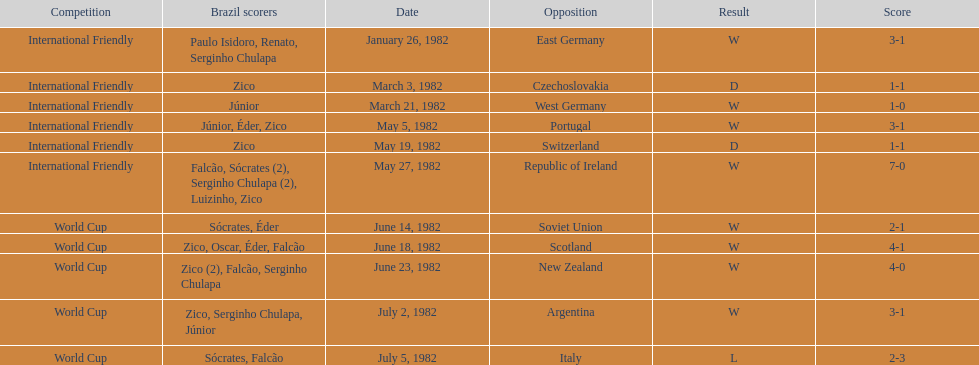What was the total number of losses brazil suffered? 1. 